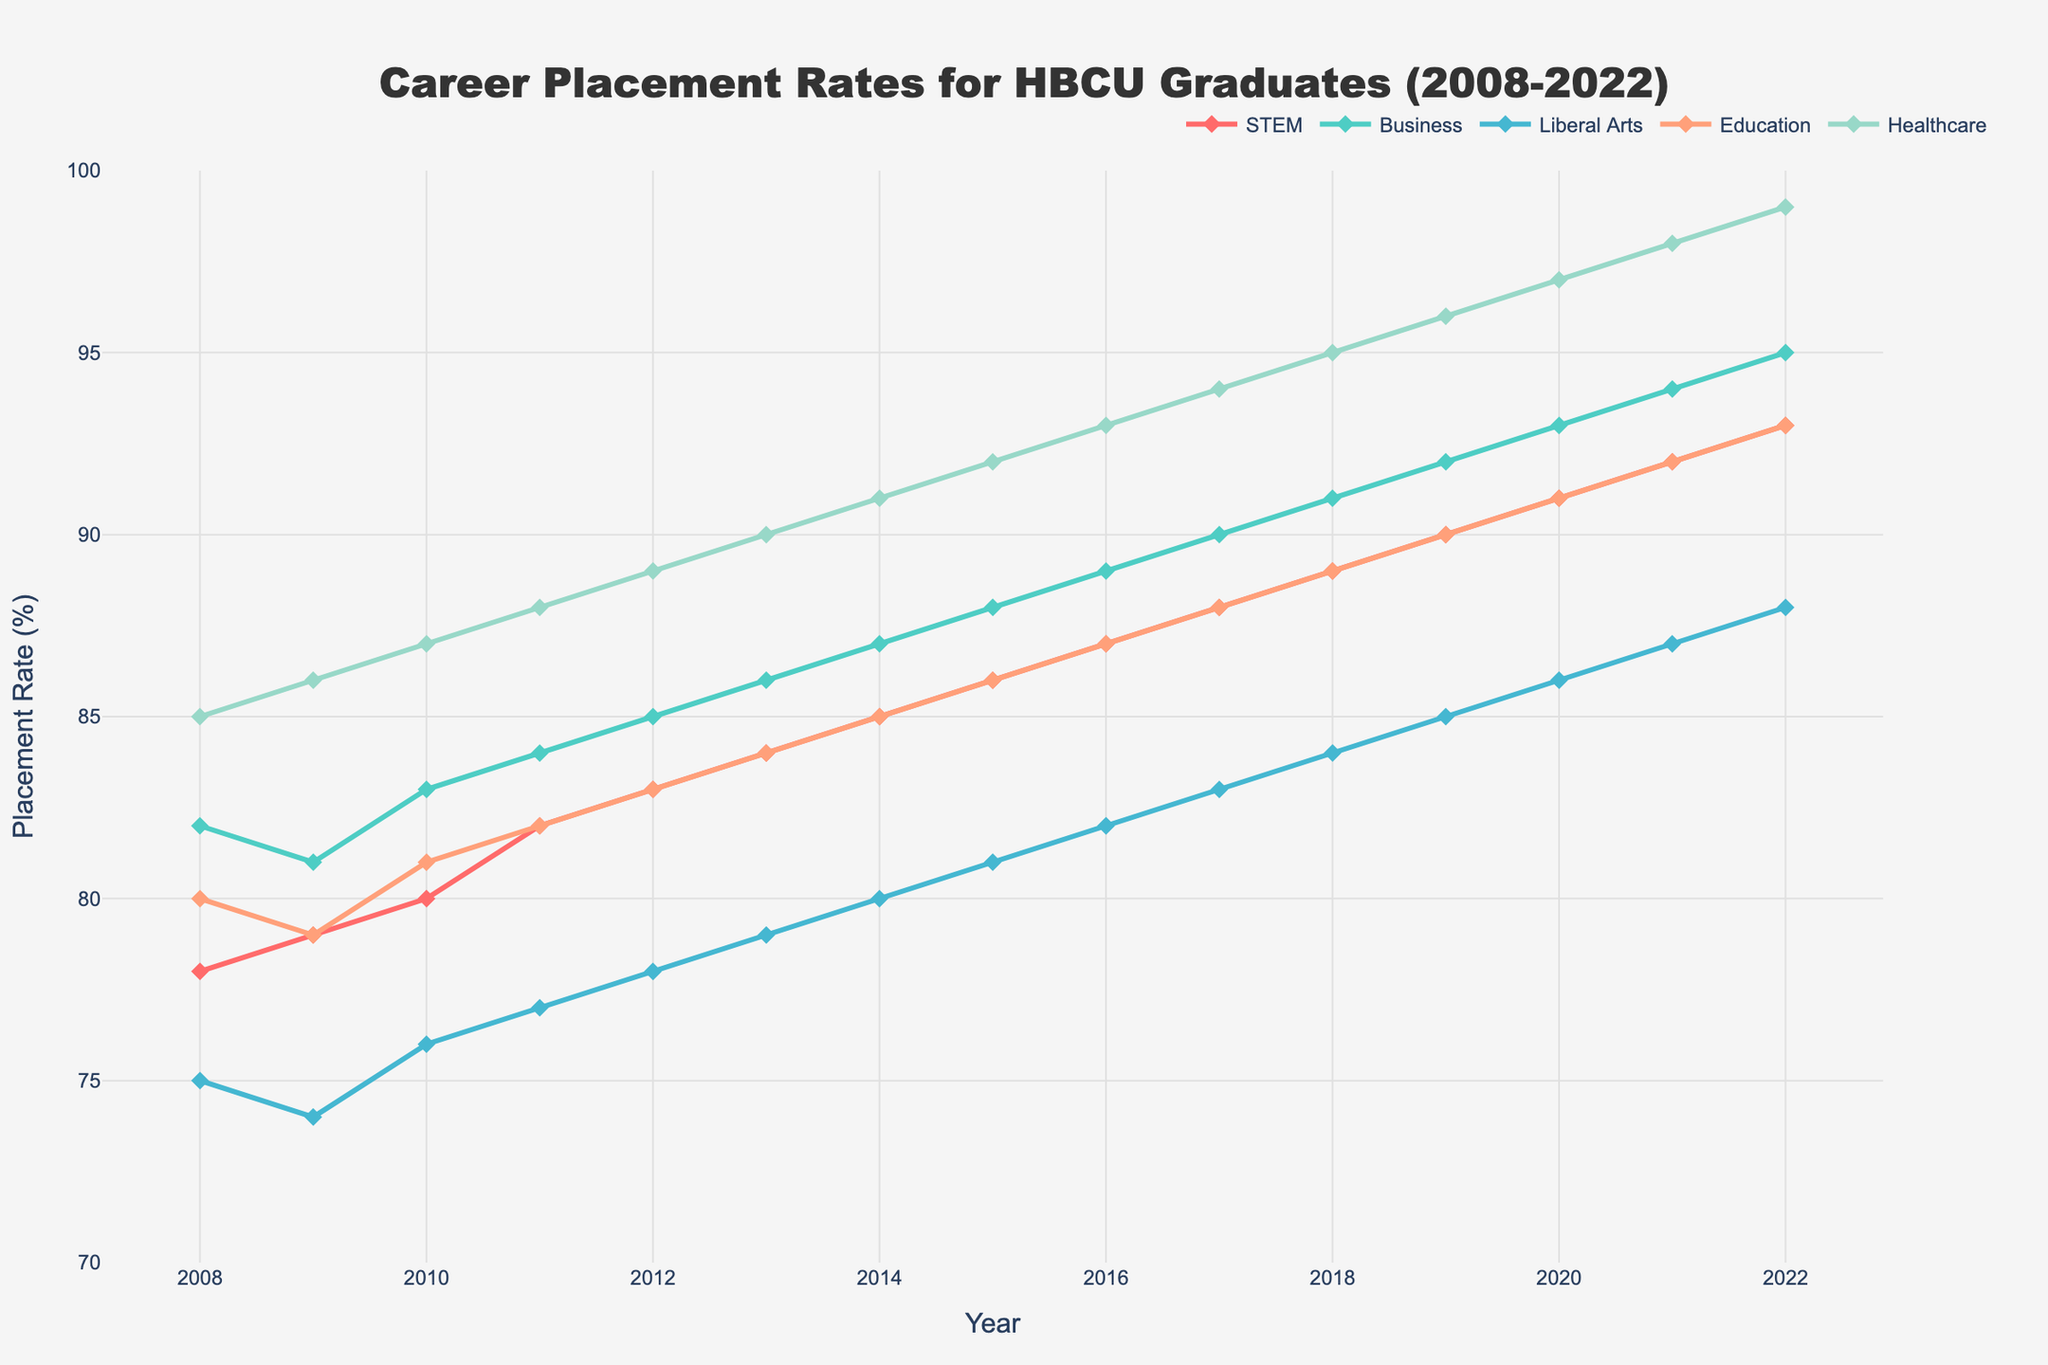What's the overall trend in the career placement rates for HBCU graduates from 2008 to 2022? The trend for career placement rates across all fields shows a steady increase over the 15-year period. Each line on the chart slopes upwards, indicating improving job placement rates for graduates.
Answer: Increasing Which field had the highest placement rate in 2022? Inspect the endpoints of all lines on the chart for the year 2022. The healthcare field ends at the highest point, indicating the highest placement rate.
Answer: Healthcare How does the placement rate for Business graduates in 2015 compare to STEM graduates in the same year? Locate the points for Business and STEM in the year 2015 on the chart. Business placement rate is 88%, while STEM placement rate is 86%.
Answer: Business > STEM What was the average placement rate for Education graduates over the 15-year period? Add the placement rates for Education graduates across all years and divide by 15 (80+79+81+82+83+84+85+86+87+88+89+90+91+92+93) / 15 = 1272 / 15 = 84.8
Answer: 84.8 Which year had the greatest increase in placement rates for Liberal Arts graduates compared to the previous year? Calculate the differences for each year and identify the greatest value. The differences are: 2009 (-1), 2010 (2), 2011 (1), 2012 (1), 2013 (1), 2014 (1), 2015 (1), 2016 (1), 2017 (1), 2018 (1), 2019 (1), 2020 (1), 2021 (1), 2022 (1). The greatest increase is from 2009 to 2010.
Answer: 2009-2010 What was the difference in placement rates between the highest and lowest fields in 2020? Identify the placement rates in the year 2020 for all fields and find the difference between the highest (Healthcare) and lowest (Liberal Arts) values: 97 - 86 = 11
Answer: 11 Which field saw a consistent year-over-year increase in placement rates with no declines? Check each field's line for any year-over-year declines. Healthcare is the field that consistently increased every year.
Answer: Healthcare In which year did STEM graduates surpass a 90% placement rate? Look for the point where the STEM line crosses the 90% mark. This occurs in the year 2019.
Answer: 2019 How did the placement rate for STEM graduates change from 2008 to 2022? Find the initial and final values for STEM graduates and calculate the difference: 93 (2022) - 78 (2008) = 15
Answer: 15 